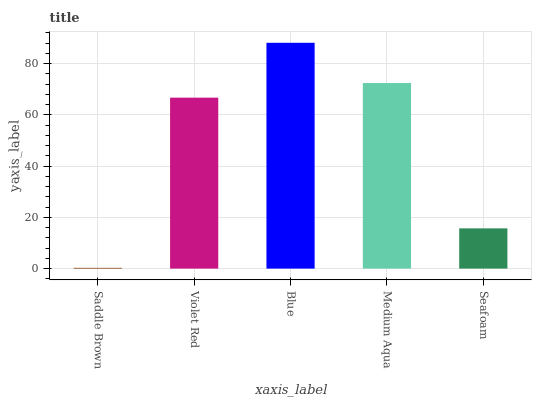Is Saddle Brown the minimum?
Answer yes or no. Yes. Is Blue the maximum?
Answer yes or no. Yes. Is Violet Red the minimum?
Answer yes or no. No. Is Violet Red the maximum?
Answer yes or no. No. Is Violet Red greater than Saddle Brown?
Answer yes or no. Yes. Is Saddle Brown less than Violet Red?
Answer yes or no. Yes. Is Saddle Brown greater than Violet Red?
Answer yes or no. No. Is Violet Red less than Saddle Brown?
Answer yes or no. No. Is Violet Red the high median?
Answer yes or no. Yes. Is Violet Red the low median?
Answer yes or no. Yes. Is Blue the high median?
Answer yes or no. No. Is Seafoam the low median?
Answer yes or no. No. 